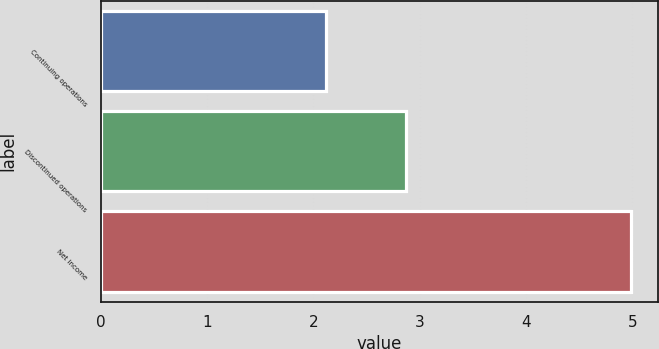<chart> <loc_0><loc_0><loc_500><loc_500><bar_chart><fcel>Continuing operations<fcel>Discontinued operations<fcel>Net income<nl><fcel>2.12<fcel>2.87<fcel>4.99<nl></chart> 